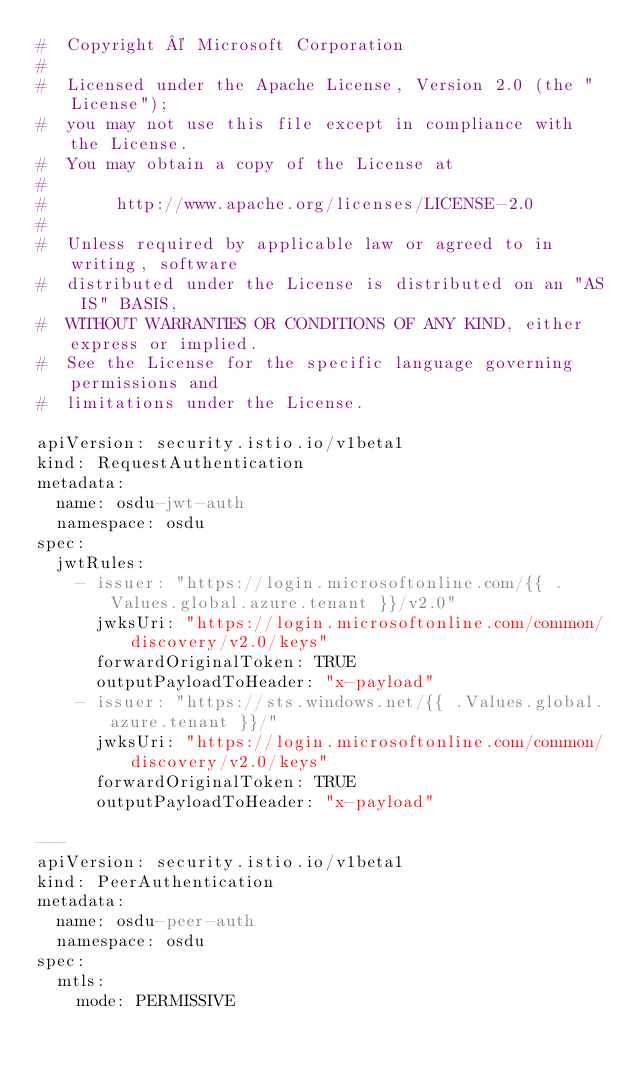<code> <loc_0><loc_0><loc_500><loc_500><_YAML_>#  Copyright © Microsoft Corporation
#
#  Licensed under the Apache License, Version 2.0 (the "License");
#  you may not use this file except in compliance with the License.
#  You may obtain a copy of the License at
#
#       http://www.apache.org/licenses/LICENSE-2.0
#
#  Unless required by applicable law or agreed to in writing, software
#  distributed under the License is distributed on an "AS IS" BASIS,
#  WITHOUT WARRANTIES OR CONDITIONS OF ANY KIND, either express or implied.
#  See the License for the specific language governing permissions and
#  limitations under the License.

apiVersion: security.istio.io/v1beta1
kind: RequestAuthentication
metadata:
  name: osdu-jwt-auth
  namespace: osdu
spec:
  jwtRules:
    - issuer: "https://login.microsoftonline.com/{{ .Values.global.azure.tenant }}/v2.0"
      jwksUri: "https://login.microsoftonline.com/common/discovery/v2.0/keys"
      forwardOriginalToken: TRUE
      outputPayloadToHeader: "x-payload"
    - issuer: "https://sts.windows.net/{{ .Values.global.azure.tenant }}/"
      jwksUri: "https://login.microsoftonline.com/common/discovery/v2.0/keys"
      forwardOriginalToken: TRUE
      outputPayloadToHeader: "x-payload"

---
apiVersion: security.istio.io/v1beta1
kind: PeerAuthentication
metadata:
  name: osdu-peer-auth
  namespace: osdu
spec:
  mtls:
    mode: PERMISSIVE
</code> 